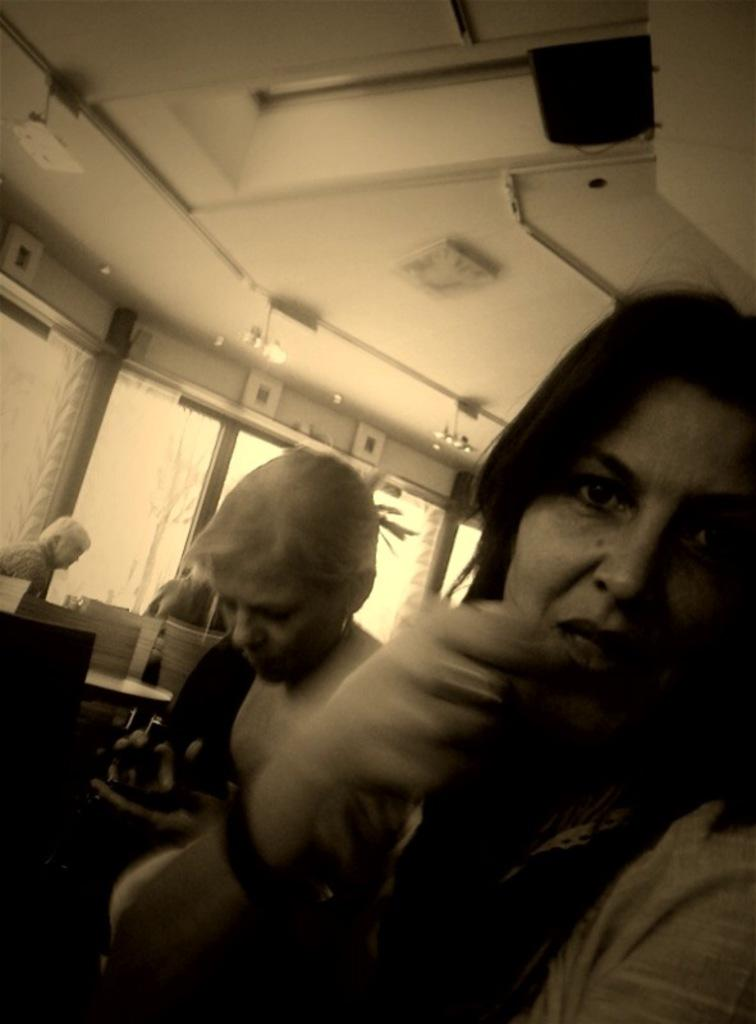How many people are in the image? There are people in the image, but the exact number is not specified. What is the primary object in the image? There is a table in the image. What can be seen through the windows in the image? The presence of windows suggests that there is a view outside, but the specifics are not mentioned. What type of window treatment is present in the image? There are curtains in the image. What type of vegetation is visible in the image? There are plants in the image. What is the bottle used for in the image? The purpose of the bottle is not specified in the facts. What type of lighting is present in the image? There are lights in the image. What type of tray is being used for teaching in the image? There is no tray present in the image, and no teaching activity is depicted. 